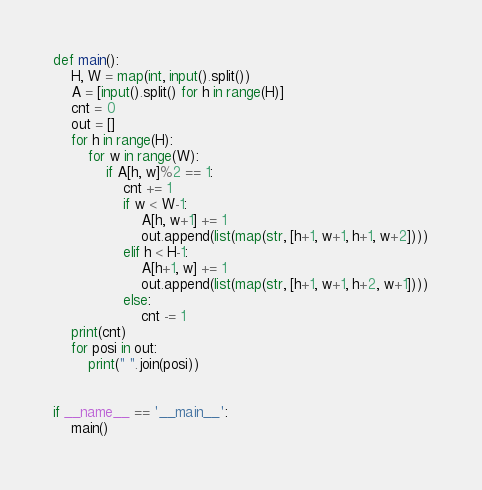<code> <loc_0><loc_0><loc_500><loc_500><_Python_>def main():
    H, W = map(int, input().split())
    A = [input().split() for h in range(H)]
    cnt = 0
    out = []
    for h in range(H):
        for w in range(W):
            if A[h, w]%2 == 1:
                cnt += 1
                if w < W-1:
                    A[h, w+1] += 1
                    out.append(list(map(str, [h+1, w+1, h+1, w+2])))
                elif h < H-1:
                    A[h+1, w] += 1
                    out.append(list(map(str, [h+1, w+1, h+2, w+1])))
                else:
                    cnt -= 1
    print(cnt)
    for posi in out:
        print(" ".join(posi))


if __name__ == '__main__':
    main()</code> 